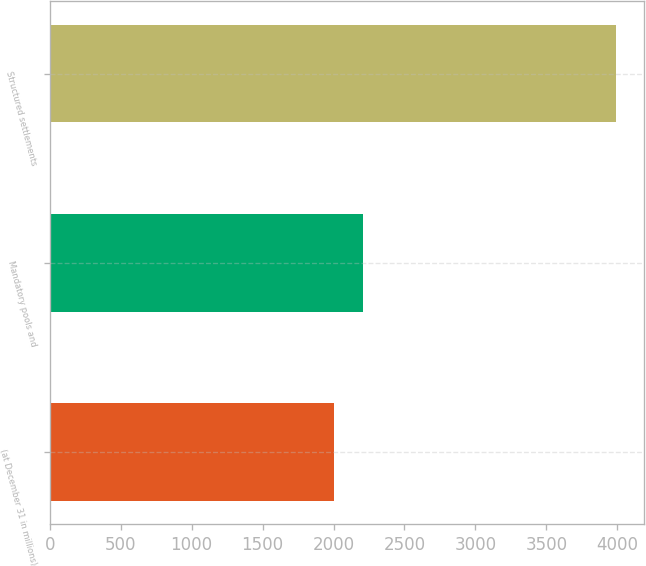Convert chart to OTSL. <chart><loc_0><loc_0><loc_500><loc_500><bar_chart><fcel>(at December 31 in millions)<fcel>Mandatory pools and<fcel>Structured settlements<nl><fcel>2005<fcel>2211<fcel>3990<nl></chart> 